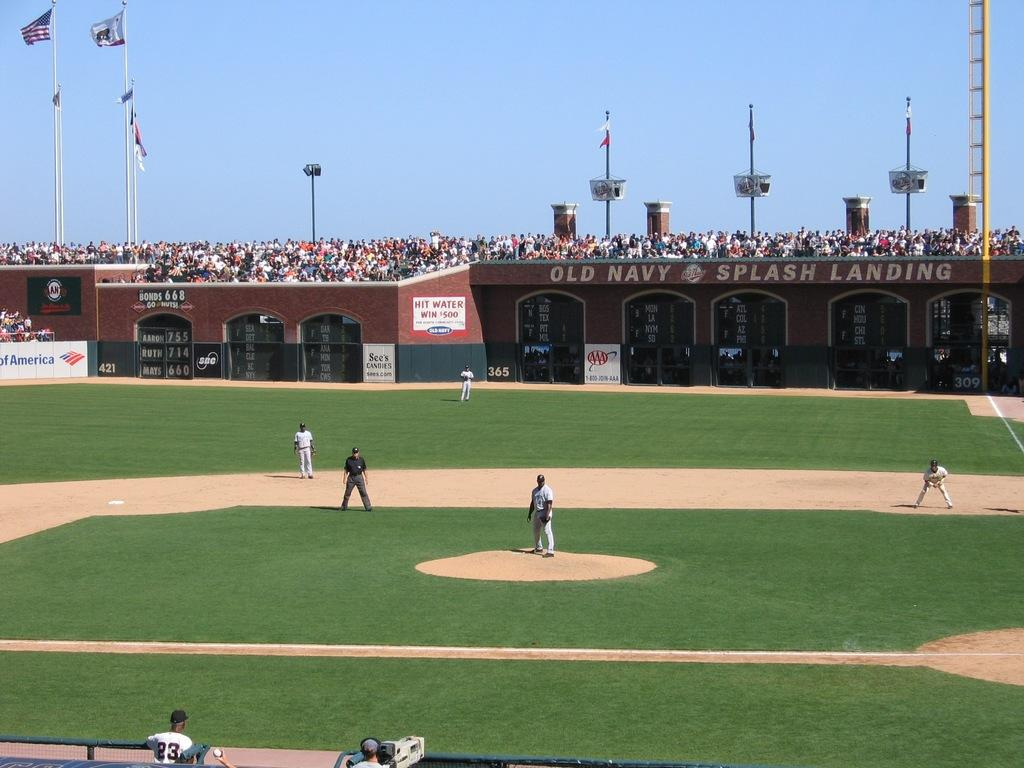Provide a one-sentence caption for the provided image. a baseball stadium with a sign that says 'hit water win $500'. 